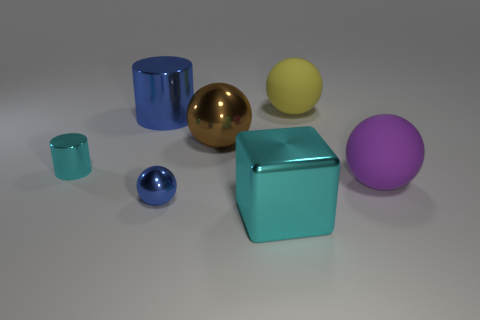The shiny cylinder that is the same size as the cyan shiny block is what color?
Ensure brevity in your answer.  Blue. Is there a metal thing of the same color as the tiny sphere?
Keep it short and to the point. Yes. What size is the cyan cylinder that is the same material as the blue ball?
Keep it short and to the point. Small. What is the size of the cylinder that is the same color as the large cube?
Offer a very short reply. Small. What number of other things are there of the same size as the blue metal sphere?
Offer a very short reply. 1. There is a ball that is behind the large brown shiny ball; what is its material?
Give a very brief answer. Rubber. There is a cyan metal thing that is in front of the large rubber object that is in front of the big ball that is on the left side of the cyan cube; what shape is it?
Offer a terse response. Cube. Do the yellow matte object and the cyan shiny cylinder have the same size?
Your answer should be very brief. No. What number of things are metal objects or small shiny cylinders that are on the left side of the cyan metallic block?
Make the answer very short. 5. What number of things are either matte spheres behind the blue metallic cylinder or things left of the big purple rubber thing?
Keep it short and to the point. 6. 